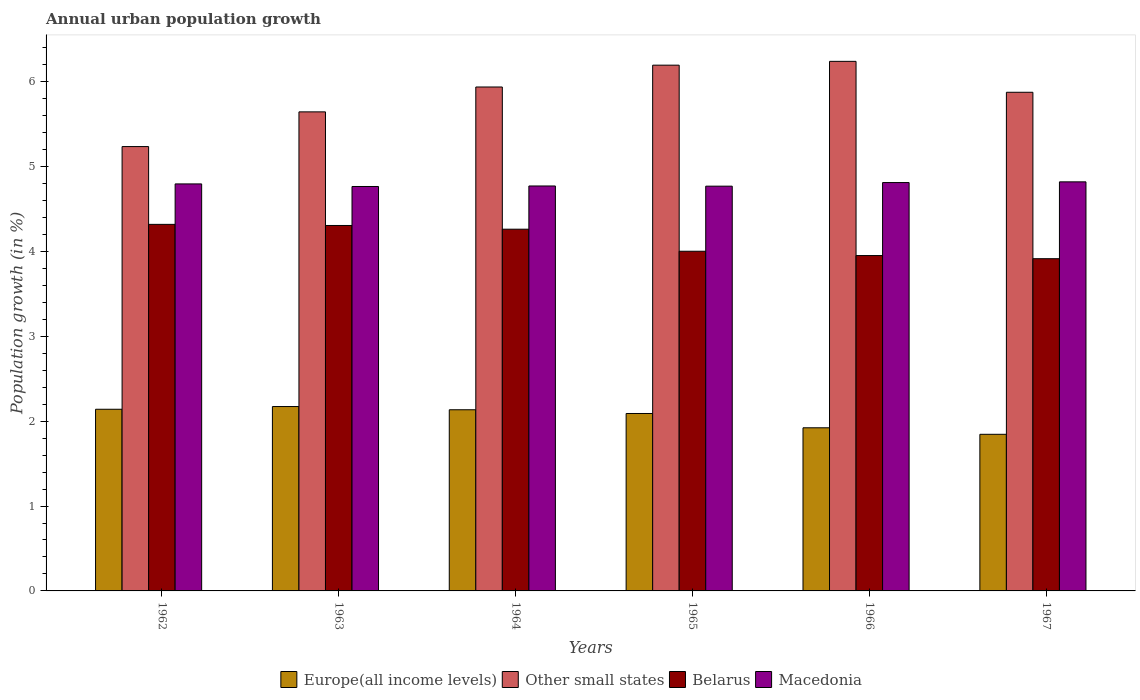Are the number of bars on each tick of the X-axis equal?
Provide a succinct answer. Yes. How many bars are there on the 3rd tick from the left?
Your answer should be compact. 4. What is the label of the 4th group of bars from the left?
Make the answer very short. 1965. In how many cases, is the number of bars for a given year not equal to the number of legend labels?
Your response must be concise. 0. What is the percentage of urban population growth in Europe(all income levels) in 1964?
Your response must be concise. 2.13. Across all years, what is the maximum percentage of urban population growth in Macedonia?
Keep it short and to the point. 4.82. Across all years, what is the minimum percentage of urban population growth in Macedonia?
Your response must be concise. 4.76. In which year was the percentage of urban population growth in Belarus minimum?
Offer a very short reply. 1967. What is the total percentage of urban population growth in Europe(all income levels) in the graph?
Your response must be concise. 12.3. What is the difference between the percentage of urban population growth in Other small states in 1964 and that in 1966?
Provide a succinct answer. -0.3. What is the difference between the percentage of urban population growth in Belarus in 1963 and the percentage of urban population growth in Macedonia in 1964?
Offer a terse response. -0.47. What is the average percentage of urban population growth in Europe(all income levels) per year?
Your response must be concise. 2.05. In the year 1964, what is the difference between the percentage of urban population growth in Other small states and percentage of urban population growth in Europe(all income levels)?
Provide a short and direct response. 3.8. In how many years, is the percentage of urban population growth in Belarus greater than 3.8 %?
Keep it short and to the point. 6. What is the ratio of the percentage of urban population growth in Belarus in 1963 to that in 1967?
Your answer should be compact. 1.1. Is the difference between the percentage of urban population growth in Other small states in 1962 and 1965 greater than the difference between the percentage of urban population growth in Europe(all income levels) in 1962 and 1965?
Provide a succinct answer. No. What is the difference between the highest and the second highest percentage of urban population growth in Europe(all income levels)?
Ensure brevity in your answer.  0.03. What is the difference between the highest and the lowest percentage of urban population growth in Macedonia?
Provide a succinct answer. 0.05. In how many years, is the percentage of urban population growth in Other small states greater than the average percentage of urban population growth in Other small states taken over all years?
Provide a succinct answer. 4. What does the 4th bar from the left in 1964 represents?
Provide a short and direct response. Macedonia. What does the 3rd bar from the right in 1963 represents?
Give a very brief answer. Other small states. Is it the case that in every year, the sum of the percentage of urban population growth in Europe(all income levels) and percentage of urban population growth in Belarus is greater than the percentage of urban population growth in Macedonia?
Provide a short and direct response. Yes. Are all the bars in the graph horizontal?
Offer a terse response. No. Are the values on the major ticks of Y-axis written in scientific E-notation?
Ensure brevity in your answer.  No. Does the graph contain any zero values?
Give a very brief answer. No. Where does the legend appear in the graph?
Provide a short and direct response. Bottom center. How are the legend labels stacked?
Offer a terse response. Horizontal. What is the title of the graph?
Your response must be concise. Annual urban population growth. What is the label or title of the Y-axis?
Provide a short and direct response. Population growth (in %). What is the Population growth (in %) in Europe(all income levels) in 1962?
Offer a very short reply. 2.14. What is the Population growth (in %) in Other small states in 1962?
Offer a terse response. 5.23. What is the Population growth (in %) in Belarus in 1962?
Your answer should be very brief. 4.32. What is the Population growth (in %) of Macedonia in 1962?
Provide a short and direct response. 4.79. What is the Population growth (in %) in Europe(all income levels) in 1963?
Offer a very short reply. 2.17. What is the Population growth (in %) of Other small states in 1963?
Your answer should be very brief. 5.64. What is the Population growth (in %) of Belarus in 1963?
Offer a terse response. 4.31. What is the Population growth (in %) of Macedonia in 1963?
Give a very brief answer. 4.76. What is the Population growth (in %) of Europe(all income levels) in 1964?
Provide a succinct answer. 2.13. What is the Population growth (in %) of Other small states in 1964?
Give a very brief answer. 5.94. What is the Population growth (in %) of Belarus in 1964?
Provide a short and direct response. 4.26. What is the Population growth (in %) of Macedonia in 1964?
Provide a short and direct response. 4.77. What is the Population growth (in %) in Europe(all income levels) in 1965?
Ensure brevity in your answer.  2.09. What is the Population growth (in %) in Other small states in 1965?
Keep it short and to the point. 6.19. What is the Population growth (in %) in Belarus in 1965?
Provide a succinct answer. 4. What is the Population growth (in %) of Macedonia in 1965?
Give a very brief answer. 4.77. What is the Population growth (in %) in Europe(all income levels) in 1966?
Your response must be concise. 1.92. What is the Population growth (in %) of Other small states in 1966?
Make the answer very short. 6.24. What is the Population growth (in %) of Belarus in 1966?
Give a very brief answer. 3.95. What is the Population growth (in %) of Macedonia in 1966?
Make the answer very short. 4.81. What is the Population growth (in %) of Europe(all income levels) in 1967?
Give a very brief answer. 1.85. What is the Population growth (in %) in Other small states in 1967?
Offer a terse response. 5.87. What is the Population growth (in %) in Belarus in 1967?
Offer a terse response. 3.91. What is the Population growth (in %) in Macedonia in 1967?
Ensure brevity in your answer.  4.82. Across all years, what is the maximum Population growth (in %) in Europe(all income levels)?
Your answer should be very brief. 2.17. Across all years, what is the maximum Population growth (in %) of Other small states?
Provide a succinct answer. 6.24. Across all years, what is the maximum Population growth (in %) of Belarus?
Your answer should be compact. 4.32. Across all years, what is the maximum Population growth (in %) in Macedonia?
Provide a short and direct response. 4.82. Across all years, what is the minimum Population growth (in %) in Europe(all income levels)?
Your response must be concise. 1.85. Across all years, what is the minimum Population growth (in %) of Other small states?
Ensure brevity in your answer.  5.23. Across all years, what is the minimum Population growth (in %) of Belarus?
Ensure brevity in your answer.  3.91. Across all years, what is the minimum Population growth (in %) of Macedonia?
Your answer should be very brief. 4.76. What is the total Population growth (in %) of Europe(all income levels) in the graph?
Give a very brief answer. 12.3. What is the total Population growth (in %) in Other small states in the graph?
Your answer should be very brief. 35.12. What is the total Population growth (in %) of Belarus in the graph?
Offer a very short reply. 24.75. What is the total Population growth (in %) of Macedonia in the graph?
Your answer should be very brief. 28.73. What is the difference between the Population growth (in %) of Europe(all income levels) in 1962 and that in 1963?
Your answer should be very brief. -0.03. What is the difference between the Population growth (in %) of Other small states in 1962 and that in 1963?
Your answer should be very brief. -0.41. What is the difference between the Population growth (in %) of Belarus in 1962 and that in 1963?
Offer a very short reply. 0.01. What is the difference between the Population growth (in %) in Macedonia in 1962 and that in 1963?
Provide a succinct answer. 0.03. What is the difference between the Population growth (in %) in Europe(all income levels) in 1962 and that in 1964?
Keep it short and to the point. 0.01. What is the difference between the Population growth (in %) of Other small states in 1962 and that in 1964?
Give a very brief answer. -0.7. What is the difference between the Population growth (in %) of Belarus in 1962 and that in 1964?
Offer a very short reply. 0.06. What is the difference between the Population growth (in %) of Macedonia in 1962 and that in 1964?
Provide a succinct answer. 0.02. What is the difference between the Population growth (in %) in Europe(all income levels) in 1962 and that in 1965?
Provide a short and direct response. 0.05. What is the difference between the Population growth (in %) of Other small states in 1962 and that in 1965?
Provide a succinct answer. -0.96. What is the difference between the Population growth (in %) of Belarus in 1962 and that in 1965?
Make the answer very short. 0.32. What is the difference between the Population growth (in %) in Macedonia in 1962 and that in 1965?
Provide a short and direct response. 0.03. What is the difference between the Population growth (in %) of Europe(all income levels) in 1962 and that in 1966?
Keep it short and to the point. 0.22. What is the difference between the Population growth (in %) in Other small states in 1962 and that in 1966?
Your answer should be compact. -1. What is the difference between the Population growth (in %) in Belarus in 1962 and that in 1966?
Your answer should be compact. 0.37. What is the difference between the Population growth (in %) of Macedonia in 1962 and that in 1966?
Keep it short and to the point. -0.02. What is the difference between the Population growth (in %) in Europe(all income levels) in 1962 and that in 1967?
Ensure brevity in your answer.  0.29. What is the difference between the Population growth (in %) of Other small states in 1962 and that in 1967?
Provide a succinct answer. -0.64. What is the difference between the Population growth (in %) in Belarus in 1962 and that in 1967?
Offer a terse response. 0.4. What is the difference between the Population growth (in %) of Macedonia in 1962 and that in 1967?
Provide a short and direct response. -0.02. What is the difference between the Population growth (in %) in Europe(all income levels) in 1963 and that in 1964?
Your response must be concise. 0.04. What is the difference between the Population growth (in %) in Other small states in 1963 and that in 1964?
Ensure brevity in your answer.  -0.29. What is the difference between the Population growth (in %) in Belarus in 1963 and that in 1964?
Ensure brevity in your answer.  0.04. What is the difference between the Population growth (in %) in Macedonia in 1963 and that in 1964?
Offer a terse response. -0.01. What is the difference between the Population growth (in %) of Europe(all income levels) in 1963 and that in 1965?
Your answer should be compact. 0.08. What is the difference between the Population growth (in %) of Other small states in 1963 and that in 1965?
Your response must be concise. -0.55. What is the difference between the Population growth (in %) of Belarus in 1963 and that in 1965?
Your answer should be very brief. 0.3. What is the difference between the Population growth (in %) of Macedonia in 1963 and that in 1965?
Offer a very short reply. -0. What is the difference between the Population growth (in %) in Europe(all income levels) in 1963 and that in 1966?
Your answer should be very brief. 0.25. What is the difference between the Population growth (in %) in Other small states in 1963 and that in 1966?
Your answer should be very brief. -0.6. What is the difference between the Population growth (in %) of Belarus in 1963 and that in 1966?
Provide a short and direct response. 0.35. What is the difference between the Population growth (in %) in Macedonia in 1963 and that in 1966?
Your answer should be compact. -0.05. What is the difference between the Population growth (in %) in Europe(all income levels) in 1963 and that in 1967?
Keep it short and to the point. 0.33. What is the difference between the Population growth (in %) of Other small states in 1963 and that in 1967?
Offer a very short reply. -0.23. What is the difference between the Population growth (in %) in Belarus in 1963 and that in 1967?
Your response must be concise. 0.39. What is the difference between the Population growth (in %) in Macedonia in 1963 and that in 1967?
Keep it short and to the point. -0.05. What is the difference between the Population growth (in %) in Europe(all income levels) in 1964 and that in 1965?
Offer a very short reply. 0.04. What is the difference between the Population growth (in %) of Other small states in 1964 and that in 1965?
Offer a terse response. -0.26. What is the difference between the Population growth (in %) in Belarus in 1964 and that in 1965?
Make the answer very short. 0.26. What is the difference between the Population growth (in %) in Macedonia in 1964 and that in 1965?
Offer a very short reply. 0. What is the difference between the Population growth (in %) of Europe(all income levels) in 1964 and that in 1966?
Offer a very short reply. 0.21. What is the difference between the Population growth (in %) of Other small states in 1964 and that in 1966?
Your response must be concise. -0.3. What is the difference between the Population growth (in %) in Belarus in 1964 and that in 1966?
Your answer should be compact. 0.31. What is the difference between the Population growth (in %) of Macedonia in 1964 and that in 1966?
Offer a terse response. -0.04. What is the difference between the Population growth (in %) of Europe(all income levels) in 1964 and that in 1967?
Offer a very short reply. 0.29. What is the difference between the Population growth (in %) in Other small states in 1964 and that in 1967?
Make the answer very short. 0.06. What is the difference between the Population growth (in %) in Belarus in 1964 and that in 1967?
Give a very brief answer. 0.35. What is the difference between the Population growth (in %) in Macedonia in 1964 and that in 1967?
Your response must be concise. -0.05. What is the difference between the Population growth (in %) in Europe(all income levels) in 1965 and that in 1966?
Your response must be concise. 0.17. What is the difference between the Population growth (in %) in Other small states in 1965 and that in 1966?
Your answer should be very brief. -0.04. What is the difference between the Population growth (in %) of Belarus in 1965 and that in 1966?
Give a very brief answer. 0.05. What is the difference between the Population growth (in %) of Macedonia in 1965 and that in 1966?
Give a very brief answer. -0.04. What is the difference between the Population growth (in %) of Europe(all income levels) in 1965 and that in 1967?
Make the answer very short. 0.25. What is the difference between the Population growth (in %) in Other small states in 1965 and that in 1967?
Your answer should be compact. 0.32. What is the difference between the Population growth (in %) in Belarus in 1965 and that in 1967?
Your response must be concise. 0.09. What is the difference between the Population growth (in %) in Macedonia in 1965 and that in 1967?
Make the answer very short. -0.05. What is the difference between the Population growth (in %) in Europe(all income levels) in 1966 and that in 1967?
Make the answer very short. 0.08. What is the difference between the Population growth (in %) of Other small states in 1966 and that in 1967?
Offer a very short reply. 0.36. What is the difference between the Population growth (in %) of Belarus in 1966 and that in 1967?
Your answer should be very brief. 0.04. What is the difference between the Population growth (in %) in Macedonia in 1966 and that in 1967?
Keep it short and to the point. -0.01. What is the difference between the Population growth (in %) of Europe(all income levels) in 1962 and the Population growth (in %) of Other small states in 1963?
Your answer should be very brief. -3.5. What is the difference between the Population growth (in %) of Europe(all income levels) in 1962 and the Population growth (in %) of Belarus in 1963?
Ensure brevity in your answer.  -2.17. What is the difference between the Population growth (in %) in Europe(all income levels) in 1962 and the Population growth (in %) in Macedonia in 1963?
Make the answer very short. -2.62. What is the difference between the Population growth (in %) in Other small states in 1962 and the Population growth (in %) in Belarus in 1963?
Provide a short and direct response. 0.93. What is the difference between the Population growth (in %) in Other small states in 1962 and the Population growth (in %) in Macedonia in 1963?
Give a very brief answer. 0.47. What is the difference between the Population growth (in %) of Belarus in 1962 and the Population growth (in %) of Macedonia in 1963?
Your answer should be compact. -0.45. What is the difference between the Population growth (in %) of Europe(all income levels) in 1962 and the Population growth (in %) of Other small states in 1964?
Provide a short and direct response. -3.8. What is the difference between the Population growth (in %) of Europe(all income levels) in 1962 and the Population growth (in %) of Belarus in 1964?
Provide a short and direct response. -2.12. What is the difference between the Population growth (in %) of Europe(all income levels) in 1962 and the Population growth (in %) of Macedonia in 1964?
Offer a very short reply. -2.63. What is the difference between the Population growth (in %) of Other small states in 1962 and the Population growth (in %) of Belarus in 1964?
Your answer should be compact. 0.97. What is the difference between the Population growth (in %) of Other small states in 1962 and the Population growth (in %) of Macedonia in 1964?
Your response must be concise. 0.46. What is the difference between the Population growth (in %) of Belarus in 1962 and the Population growth (in %) of Macedonia in 1964?
Offer a terse response. -0.45. What is the difference between the Population growth (in %) of Europe(all income levels) in 1962 and the Population growth (in %) of Other small states in 1965?
Ensure brevity in your answer.  -4.05. What is the difference between the Population growth (in %) in Europe(all income levels) in 1962 and the Population growth (in %) in Belarus in 1965?
Keep it short and to the point. -1.86. What is the difference between the Population growth (in %) of Europe(all income levels) in 1962 and the Population growth (in %) of Macedonia in 1965?
Keep it short and to the point. -2.63. What is the difference between the Population growth (in %) in Other small states in 1962 and the Population growth (in %) in Belarus in 1965?
Provide a succinct answer. 1.23. What is the difference between the Population growth (in %) of Other small states in 1962 and the Population growth (in %) of Macedonia in 1965?
Provide a short and direct response. 0.47. What is the difference between the Population growth (in %) of Belarus in 1962 and the Population growth (in %) of Macedonia in 1965?
Keep it short and to the point. -0.45. What is the difference between the Population growth (in %) of Europe(all income levels) in 1962 and the Population growth (in %) of Other small states in 1966?
Ensure brevity in your answer.  -4.1. What is the difference between the Population growth (in %) of Europe(all income levels) in 1962 and the Population growth (in %) of Belarus in 1966?
Ensure brevity in your answer.  -1.81. What is the difference between the Population growth (in %) of Europe(all income levels) in 1962 and the Population growth (in %) of Macedonia in 1966?
Your answer should be very brief. -2.67. What is the difference between the Population growth (in %) of Other small states in 1962 and the Population growth (in %) of Belarus in 1966?
Your response must be concise. 1.28. What is the difference between the Population growth (in %) in Other small states in 1962 and the Population growth (in %) in Macedonia in 1966?
Your response must be concise. 0.42. What is the difference between the Population growth (in %) of Belarus in 1962 and the Population growth (in %) of Macedonia in 1966?
Keep it short and to the point. -0.49. What is the difference between the Population growth (in %) of Europe(all income levels) in 1962 and the Population growth (in %) of Other small states in 1967?
Offer a terse response. -3.73. What is the difference between the Population growth (in %) in Europe(all income levels) in 1962 and the Population growth (in %) in Belarus in 1967?
Keep it short and to the point. -1.77. What is the difference between the Population growth (in %) of Europe(all income levels) in 1962 and the Population growth (in %) of Macedonia in 1967?
Give a very brief answer. -2.68. What is the difference between the Population growth (in %) in Other small states in 1962 and the Population growth (in %) in Belarus in 1967?
Your response must be concise. 1.32. What is the difference between the Population growth (in %) in Other small states in 1962 and the Population growth (in %) in Macedonia in 1967?
Give a very brief answer. 0.42. What is the difference between the Population growth (in %) of Belarus in 1962 and the Population growth (in %) of Macedonia in 1967?
Your answer should be compact. -0.5. What is the difference between the Population growth (in %) of Europe(all income levels) in 1963 and the Population growth (in %) of Other small states in 1964?
Ensure brevity in your answer.  -3.76. What is the difference between the Population growth (in %) in Europe(all income levels) in 1963 and the Population growth (in %) in Belarus in 1964?
Offer a terse response. -2.09. What is the difference between the Population growth (in %) in Europe(all income levels) in 1963 and the Population growth (in %) in Macedonia in 1964?
Keep it short and to the point. -2.6. What is the difference between the Population growth (in %) of Other small states in 1963 and the Population growth (in %) of Belarus in 1964?
Offer a terse response. 1.38. What is the difference between the Population growth (in %) of Other small states in 1963 and the Population growth (in %) of Macedonia in 1964?
Provide a short and direct response. 0.87. What is the difference between the Population growth (in %) in Belarus in 1963 and the Population growth (in %) in Macedonia in 1964?
Provide a succinct answer. -0.47. What is the difference between the Population growth (in %) in Europe(all income levels) in 1963 and the Population growth (in %) in Other small states in 1965?
Provide a short and direct response. -4.02. What is the difference between the Population growth (in %) in Europe(all income levels) in 1963 and the Population growth (in %) in Belarus in 1965?
Make the answer very short. -1.83. What is the difference between the Population growth (in %) of Europe(all income levels) in 1963 and the Population growth (in %) of Macedonia in 1965?
Offer a terse response. -2.6. What is the difference between the Population growth (in %) of Other small states in 1963 and the Population growth (in %) of Belarus in 1965?
Ensure brevity in your answer.  1.64. What is the difference between the Population growth (in %) in Other small states in 1963 and the Population growth (in %) in Macedonia in 1965?
Keep it short and to the point. 0.88. What is the difference between the Population growth (in %) in Belarus in 1963 and the Population growth (in %) in Macedonia in 1965?
Provide a succinct answer. -0.46. What is the difference between the Population growth (in %) of Europe(all income levels) in 1963 and the Population growth (in %) of Other small states in 1966?
Give a very brief answer. -4.07. What is the difference between the Population growth (in %) of Europe(all income levels) in 1963 and the Population growth (in %) of Belarus in 1966?
Provide a short and direct response. -1.78. What is the difference between the Population growth (in %) of Europe(all income levels) in 1963 and the Population growth (in %) of Macedonia in 1966?
Offer a terse response. -2.64. What is the difference between the Population growth (in %) in Other small states in 1963 and the Population growth (in %) in Belarus in 1966?
Give a very brief answer. 1.69. What is the difference between the Population growth (in %) in Other small states in 1963 and the Population growth (in %) in Macedonia in 1966?
Ensure brevity in your answer.  0.83. What is the difference between the Population growth (in %) in Belarus in 1963 and the Population growth (in %) in Macedonia in 1966?
Offer a very short reply. -0.51. What is the difference between the Population growth (in %) in Europe(all income levels) in 1963 and the Population growth (in %) in Other small states in 1967?
Make the answer very short. -3.7. What is the difference between the Population growth (in %) in Europe(all income levels) in 1963 and the Population growth (in %) in Belarus in 1967?
Provide a short and direct response. -1.74. What is the difference between the Population growth (in %) of Europe(all income levels) in 1963 and the Population growth (in %) of Macedonia in 1967?
Ensure brevity in your answer.  -2.65. What is the difference between the Population growth (in %) in Other small states in 1963 and the Population growth (in %) in Belarus in 1967?
Your response must be concise. 1.73. What is the difference between the Population growth (in %) in Other small states in 1963 and the Population growth (in %) in Macedonia in 1967?
Ensure brevity in your answer.  0.82. What is the difference between the Population growth (in %) in Belarus in 1963 and the Population growth (in %) in Macedonia in 1967?
Provide a short and direct response. -0.51. What is the difference between the Population growth (in %) of Europe(all income levels) in 1964 and the Population growth (in %) of Other small states in 1965?
Ensure brevity in your answer.  -4.06. What is the difference between the Population growth (in %) in Europe(all income levels) in 1964 and the Population growth (in %) in Belarus in 1965?
Provide a succinct answer. -1.87. What is the difference between the Population growth (in %) of Europe(all income levels) in 1964 and the Population growth (in %) of Macedonia in 1965?
Give a very brief answer. -2.63. What is the difference between the Population growth (in %) of Other small states in 1964 and the Population growth (in %) of Belarus in 1965?
Offer a very short reply. 1.93. What is the difference between the Population growth (in %) of Other small states in 1964 and the Population growth (in %) of Macedonia in 1965?
Make the answer very short. 1.17. What is the difference between the Population growth (in %) in Belarus in 1964 and the Population growth (in %) in Macedonia in 1965?
Keep it short and to the point. -0.51. What is the difference between the Population growth (in %) of Europe(all income levels) in 1964 and the Population growth (in %) of Other small states in 1966?
Offer a very short reply. -4.1. What is the difference between the Population growth (in %) of Europe(all income levels) in 1964 and the Population growth (in %) of Belarus in 1966?
Make the answer very short. -1.82. What is the difference between the Population growth (in %) in Europe(all income levels) in 1964 and the Population growth (in %) in Macedonia in 1966?
Provide a succinct answer. -2.68. What is the difference between the Population growth (in %) of Other small states in 1964 and the Population growth (in %) of Belarus in 1966?
Give a very brief answer. 1.99. What is the difference between the Population growth (in %) in Other small states in 1964 and the Population growth (in %) in Macedonia in 1966?
Provide a short and direct response. 1.13. What is the difference between the Population growth (in %) in Belarus in 1964 and the Population growth (in %) in Macedonia in 1966?
Offer a very short reply. -0.55. What is the difference between the Population growth (in %) in Europe(all income levels) in 1964 and the Population growth (in %) in Other small states in 1967?
Give a very brief answer. -3.74. What is the difference between the Population growth (in %) in Europe(all income levels) in 1964 and the Population growth (in %) in Belarus in 1967?
Your answer should be very brief. -1.78. What is the difference between the Population growth (in %) of Europe(all income levels) in 1964 and the Population growth (in %) of Macedonia in 1967?
Provide a succinct answer. -2.69. What is the difference between the Population growth (in %) of Other small states in 1964 and the Population growth (in %) of Belarus in 1967?
Your response must be concise. 2.02. What is the difference between the Population growth (in %) in Other small states in 1964 and the Population growth (in %) in Macedonia in 1967?
Give a very brief answer. 1.12. What is the difference between the Population growth (in %) of Belarus in 1964 and the Population growth (in %) of Macedonia in 1967?
Offer a terse response. -0.56. What is the difference between the Population growth (in %) in Europe(all income levels) in 1965 and the Population growth (in %) in Other small states in 1966?
Keep it short and to the point. -4.15. What is the difference between the Population growth (in %) of Europe(all income levels) in 1965 and the Population growth (in %) of Belarus in 1966?
Your response must be concise. -1.86. What is the difference between the Population growth (in %) of Europe(all income levels) in 1965 and the Population growth (in %) of Macedonia in 1966?
Provide a short and direct response. -2.72. What is the difference between the Population growth (in %) of Other small states in 1965 and the Population growth (in %) of Belarus in 1966?
Give a very brief answer. 2.24. What is the difference between the Population growth (in %) of Other small states in 1965 and the Population growth (in %) of Macedonia in 1966?
Your answer should be very brief. 1.38. What is the difference between the Population growth (in %) in Belarus in 1965 and the Population growth (in %) in Macedonia in 1966?
Offer a very short reply. -0.81. What is the difference between the Population growth (in %) of Europe(all income levels) in 1965 and the Population growth (in %) of Other small states in 1967?
Offer a very short reply. -3.78. What is the difference between the Population growth (in %) in Europe(all income levels) in 1965 and the Population growth (in %) in Belarus in 1967?
Your answer should be very brief. -1.82. What is the difference between the Population growth (in %) in Europe(all income levels) in 1965 and the Population growth (in %) in Macedonia in 1967?
Keep it short and to the point. -2.73. What is the difference between the Population growth (in %) of Other small states in 1965 and the Population growth (in %) of Belarus in 1967?
Keep it short and to the point. 2.28. What is the difference between the Population growth (in %) of Other small states in 1965 and the Population growth (in %) of Macedonia in 1967?
Provide a short and direct response. 1.37. What is the difference between the Population growth (in %) in Belarus in 1965 and the Population growth (in %) in Macedonia in 1967?
Your response must be concise. -0.82. What is the difference between the Population growth (in %) of Europe(all income levels) in 1966 and the Population growth (in %) of Other small states in 1967?
Provide a short and direct response. -3.95. What is the difference between the Population growth (in %) of Europe(all income levels) in 1966 and the Population growth (in %) of Belarus in 1967?
Your answer should be compact. -1.99. What is the difference between the Population growth (in %) of Europe(all income levels) in 1966 and the Population growth (in %) of Macedonia in 1967?
Your answer should be compact. -2.9. What is the difference between the Population growth (in %) of Other small states in 1966 and the Population growth (in %) of Belarus in 1967?
Your answer should be very brief. 2.32. What is the difference between the Population growth (in %) of Other small states in 1966 and the Population growth (in %) of Macedonia in 1967?
Keep it short and to the point. 1.42. What is the difference between the Population growth (in %) in Belarus in 1966 and the Population growth (in %) in Macedonia in 1967?
Provide a short and direct response. -0.87. What is the average Population growth (in %) in Europe(all income levels) per year?
Provide a succinct answer. 2.05. What is the average Population growth (in %) of Other small states per year?
Your answer should be very brief. 5.85. What is the average Population growth (in %) in Belarus per year?
Ensure brevity in your answer.  4.13. What is the average Population growth (in %) in Macedonia per year?
Give a very brief answer. 4.79. In the year 1962, what is the difference between the Population growth (in %) in Europe(all income levels) and Population growth (in %) in Other small states?
Offer a very short reply. -3.09. In the year 1962, what is the difference between the Population growth (in %) of Europe(all income levels) and Population growth (in %) of Belarus?
Keep it short and to the point. -2.18. In the year 1962, what is the difference between the Population growth (in %) of Europe(all income levels) and Population growth (in %) of Macedonia?
Provide a succinct answer. -2.65. In the year 1962, what is the difference between the Population growth (in %) of Other small states and Population growth (in %) of Belarus?
Your answer should be very brief. 0.92. In the year 1962, what is the difference between the Population growth (in %) of Other small states and Population growth (in %) of Macedonia?
Your response must be concise. 0.44. In the year 1962, what is the difference between the Population growth (in %) of Belarus and Population growth (in %) of Macedonia?
Give a very brief answer. -0.48. In the year 1963, what is the difference between the Population growth (in %) in Europe(all income levels) and Population growth (in %) in Other small states?
Keep it short and to the point. -3.47. In the year 1963, what is the difference between the Population growth (in %) of Europe(all income levels) and Population growth (in %) of Belarus?
Offer a very short reply. -2.13. In the year 1963, what is the difference between the Population growth (in %) in Europe(all income levels) and Population growth (in %) in Macedonia?
Your answer should be very brief. -2.59. In the year 1963, what is the difference between the Population growth (in %) in Other small states and Population growth (in %) in Belarus?
Ensure brevity in your answer.  1.34. In the year 1963, what is the difference between the Population growth (in %) in Other small states and Population growth (in %) in Macedonia?
Keep it short and to the point. 0.88. In the year 1963, what is the difference between the Population growth (in %) in Belarus and Population growth (in %) in Macedonia?
Give a very brief answer. -0.46. In the year 1964, what is the difference between the Population growth (in %) in Europe(all income levels) and Population growth (in %) in Other small states?
Your answer should be very brief. -3.8. In the year 1964, what is the difference between the Population growth (in %) of Europe(all income levels) and Population growth (in %) of Belarus?
Your answer should be compact. -2.13. In the year 1964, what is the difference between the Population growth (in %) in Europe(all income levels) and Population growth (in %) in Macedonia?
Your answer should be compact. -2.64. In the year 1964, what is the difference between the Population growth (in %) of Other small states and Population growth (in %) of Belarus?
Offer a terse response. 1.68. In the year 1964, what is the difference between the Population growth (in %) of Other small states and Population growth (in %) of Macedonia?
Your answer should be compact. 1.17. In the year 1964, what is the difference between the Population growth (in %) in Belarus and Population growth (in %) in Macedonia?
Keep it short and to the point. -0.51. In the year 1965, what is the difference between the Population growth (in %) in Europe(all income levels) and Population growth (in %) in Other small states?
Give a very brief answer. -4.1. In the year 1965, what is the difference between the Population growth (in %) in Europe(all income levels) and Population growth (in %) in Belarus?
Offer a terse response. -1.91. In the year 1965, what is the difference between the Population growth (in %) of Europe(all income levels) and Population growth (in %) of Macedonia?
Ensure brevity in your answer.  -2.68. In the year 1965, what is the difference between the Population growth (in %) in Other small states and Population growth (in %) in Belarus?
Your answer should be compact. 2.19. In the year 1965, what is the difference between the Population growth (in %) of Other small states and Population growth (in %) of Macedonia?
Make the answer very short. 1.43. In the year 1965, what is the difference between the Population growth (in %) of Belarus and Population growth (in %) of Macedonia?
Provide a short and direct response. -0.77. In the year 1966, what is the difference between the Population growth (in %) of Europe(all income levels) and Population growth (in %) of Other small states?
Your answer should be compact. -4.32. In the year 1966, what is the difference between the Population growth (in %) in Europe(all income levels) and Population growth (in %) in Belarus?
Give a very brief answer. -2.03. In the year 1966, what is the difference between the Population growth (in %) of Europe(all income levels) and Population growth (in %) of Macedonia?
Provide a succinct answer. -2.89. In the year 1966, what is the difference between the Population growth (in %) in Other small states and Population growth (in %) in Belarus?
Offer a terse response. 2.29. In the year 1966, what is the difference between the Population growth (in %) in Other small states and Population growth (in %) in Macedonia?
Provide a short and direct response. 1.43. In the year 1966, what is the difference between the Population growth (in %) of Belarus and Population growth (in %) of Macedonia?
Give a very brief answer. -0.86. In the year 1967, what is the difference between the Population growth (in %) in Europe(all income levels) and Population growth (in %) in Other small states?
Your answer should be very brief. -4.03. In the year 1967, what is the difference between the Population growth (in %) in Europe(all income levels) and Population growth (in %) in Belarus?
Offer a very short reply. -2.07. In the year 1967, what is the difference between the Population growth (in %) of Europe(all income levels) and Population growth (in %) of Macedonia?
Ensure brevity in your answer.  -2.97. In the year 1967, what is the difference between the Population growth (in %) in Other small states and Population growth (in %) in Belarus?
Offer a terse response. 1.96. In the year 1967, what is the difference between the Population growth (in %) of Other small states and Population growth (in %) of Macedonia?
Ensure brevity in your answer.  1.06. In the year 1967, what is the difference between the Population growth (in %) of Belarus and Population growth (in %) of Macedonia?
Your answer should be compact. -0.91. What is the ratio of the Population growth (in %) of Europe(all income levels) in 1962 to that in 1963?
Make the answer very short. 0.99. What is the ratio of the Population growth (in %) in Other small states in 1962 to that in 1963?
Your response must be concise. 0.93. What is the ratio of the Population growth (in %) of Belarus in 1962 to that in 1963?
Ensure brevity in your answer.  1. What is the ratio of the Population growth (in %) of Macedonia in 1962 to that in 1963?
Ensure brevity in your answer.  1.01. What is the ratio of the Population growth (in %) in Other small states in 1962 to that in 1964?
Keep it short and to the point. 0.88. What is the ratio of the Population growth (in %) of Belarus in 1962 to that in 1964?
Give a very brief answer. 1.01. What is the ratio of the Population growth (in %) in Europe(all income levels) in 1962 to that in 1965?
Keep it short and to the point. 1.02. What is the ratio of the Population growth (in %) in Other small states in 1962 to that in 1965?
Give a very brief answer. 0.85. What is the ratio of the Population growth (in %) of Belarus in 1962 to that in 1965?
Ensure brevity in your answer.  1.08. What is the ratio of the Population growth (in %) in Europe(all income levels) in 1962 to that in 1966?
Your answer should be compact. 1.11. What is the ratio of the Population growth (in %) in Other small states in 1962 to that in 1966?
Provide a short and direct response. 0.84. What is the ratio of the Population growth (in %) of Belarus in 1962 to that in 1966?
Provide a succinct answer. 1.09. What is the ratio of the Population growth (in %) of Europe(all income levels) in 1962 to that in 1967?
Provide a succinct answer. 1.16. What is the ratio of the Population growth (in %) in Other small states in 1962 to that in 1967?
Keep it short and to the point. 0.89. What is the ratio of the Population growth (in %) in Belarus in 1962 to that in 1967?
Give a very brief answer. 1.1. What is the ratio of the Population growth (in %) in Europe(all income levels) in 1963 to that in 1964?
Give a very brief answer. 1.02. What is the ratio of the Population growth (in %) in Other small states in 1963 to that in 1964?
Offer a very short reply. 0.95. What is the ratio of the Population growth (in %) of Belarus in 1963 to that in 1964?
Your answer should be very brief. 1.01. What is the ratio of the Population growth (in %) of Macedonia in 1963 to that in 1964?
Give a very brief answer. 1. What is the ratio of the Population growth (in %) of Europe(all income levels) in 1963 to that in 1965?
Your answer should be very brief. 1.04. What is the ratio of the Population growth (in %) in Other small states in 1963 to that in 1965?
Make the answer very short. 0.91. What is the ratio of the Population growth (in %) in Belarus in 1963 to that in 1965?
Ensure brevity in your answer.  1.08. What is the ratio of the Population growth (in %) of Europe(all income levels) in 1963 to that in 1966?
Offer a very short reply. 1.13. What is the ratio of the Population growth (in %) of Other small states in 1963 to that in 1966?
Give a very brief answer. 0.9. What is the ratio of the Population growth (in %) of Belarus in 1963 to that in 1966?
Your answer should be compact. 1.09. What is the ratio of the Population growth (in %) in Macedonia in 1963 to that in 1966?
Offer a terse response. 0.99. What is the ratio of the Population growth (in %) of Europe(all income levels) in 1963 to that in 1967?
Make the answer very short. 1.18. What is the ratio of the Population growth (in %) of Other small states in 1963 to that in 1967?
Your answer should be compact. 0.96. What is the ratio of the Population growth (in %) of Europe(all income levels) in 1964 to that in 1965?
Keep it short and to the point. 1.02. What is the ratio of the Population growth (in %) of Other small states in 1964 to that in 1965?
Your response must be concise. 0.96. What is the ratio of the Population growth (in %) of Belarus in 1964 to that in 1965?
Your answer should be very brief. 1.06. What is the ratio of the Population growth (in %) of Macedonia in 1964 to that in 1965?
Your answer should be very brief. 1. What is the ratio of the Population growth (in %) of Europe(all income levels) in 1964 to that in 1966?
Offer a terse response. 1.11. What is the ratio of the Population growth (in %) of Other small states in 1964 to that in 1966?
Give a very brief answer. 0.95. What is the ratio of the Population growth (in %) of Belarus in 1964 to that in 1966?
Your response must be concise. 1.08. What is the ratio of the Population growth (in %) of Europe(all income levels) in 1964 to that in 1967?
Provide a succinct answer. 1.16. What is the ratio of the Population growth (in %) of Other small states in 1964 to that in 1967?
Ensure brevity in your answer.  1.01. What is the ratio of the Population growth (in %) in Belarus in 1964 to that in 1967?
Your answer should be compact. 1.09. What is the ratio of the Population growth (in %) in Macedonia in 1964 to that in 1967?
Your answer should be very brief. 0.99. What is the ratio of the Population growth (in %) in Europe(all income levels) in 1965 to that in 1966?
Your response must be concise. 1.09. What is the ratio of the Population growth (in %) of Belarus in 1965 to that in 1966?
Provide a succinct answer. 1.01. What is the ratio of the Population growth (in %) in Macedonia in 1965 to that in 1966?
Your response must be concise. 0.99. What is the ratio of the Population growth (in %) of Europe(all income levels) in 1965 to that in 1967?
Your answer should be very brief. 1.13. What is the ratio of the Population growth (in %) of Other small states in 1965 to that in 1967?
Keep it short and to the point. 1.05. What is the ratio of the Population growth (in %) in Belarus in 1965 to that in 1967?
Ensure brevity in your answer.  1.02. What is the ratio of the Population growth (in %) of Europe(all income levels) in 1966 to that in 1967?
Give a very brief answer. 1.04. What is the ratio of the Population growth (in %) in Other small states in 1966 to that in 1967?
Provide a succinct answer. 1.06. What is the ratio of the Population growth (in %) of Belarus in 1966 to that in 1967?
Provide a succinct answer. 1.01. What is the difference between the highest and the second highest Population growth (in %) in Europe(all income levels)?
Ensure brevity in your answer.  0.03. What is the difference between the highest and the second highest Population growth (in %) of Other small states?
Ensure brevity in your answer.  0.04. What is the difference between the highest and the second highest Population growth (in %) of Belarus?
Make the answer very short. 0.01. What is the difference between the highest and the second highest Population growth (in %) in Macedonia?
Your answer should be very brief. 0.01. What is the difference between the highest and the lowest Population growth (in %) in Europe(all income levels)?
Your answer should be compact. 0.33. What is the difference between the highest and the lowest Population growth (in %) of Other small states?
Make the answer very short. 1. What is the difference between the highest and the lowest Population growth (in %) in Belarus?
Your answer should be very brief. 0.4. What is the difference between the highest and the lowest Population growth (in %) in Macedonia?
Ensure brevity in your answer.  0.05. 